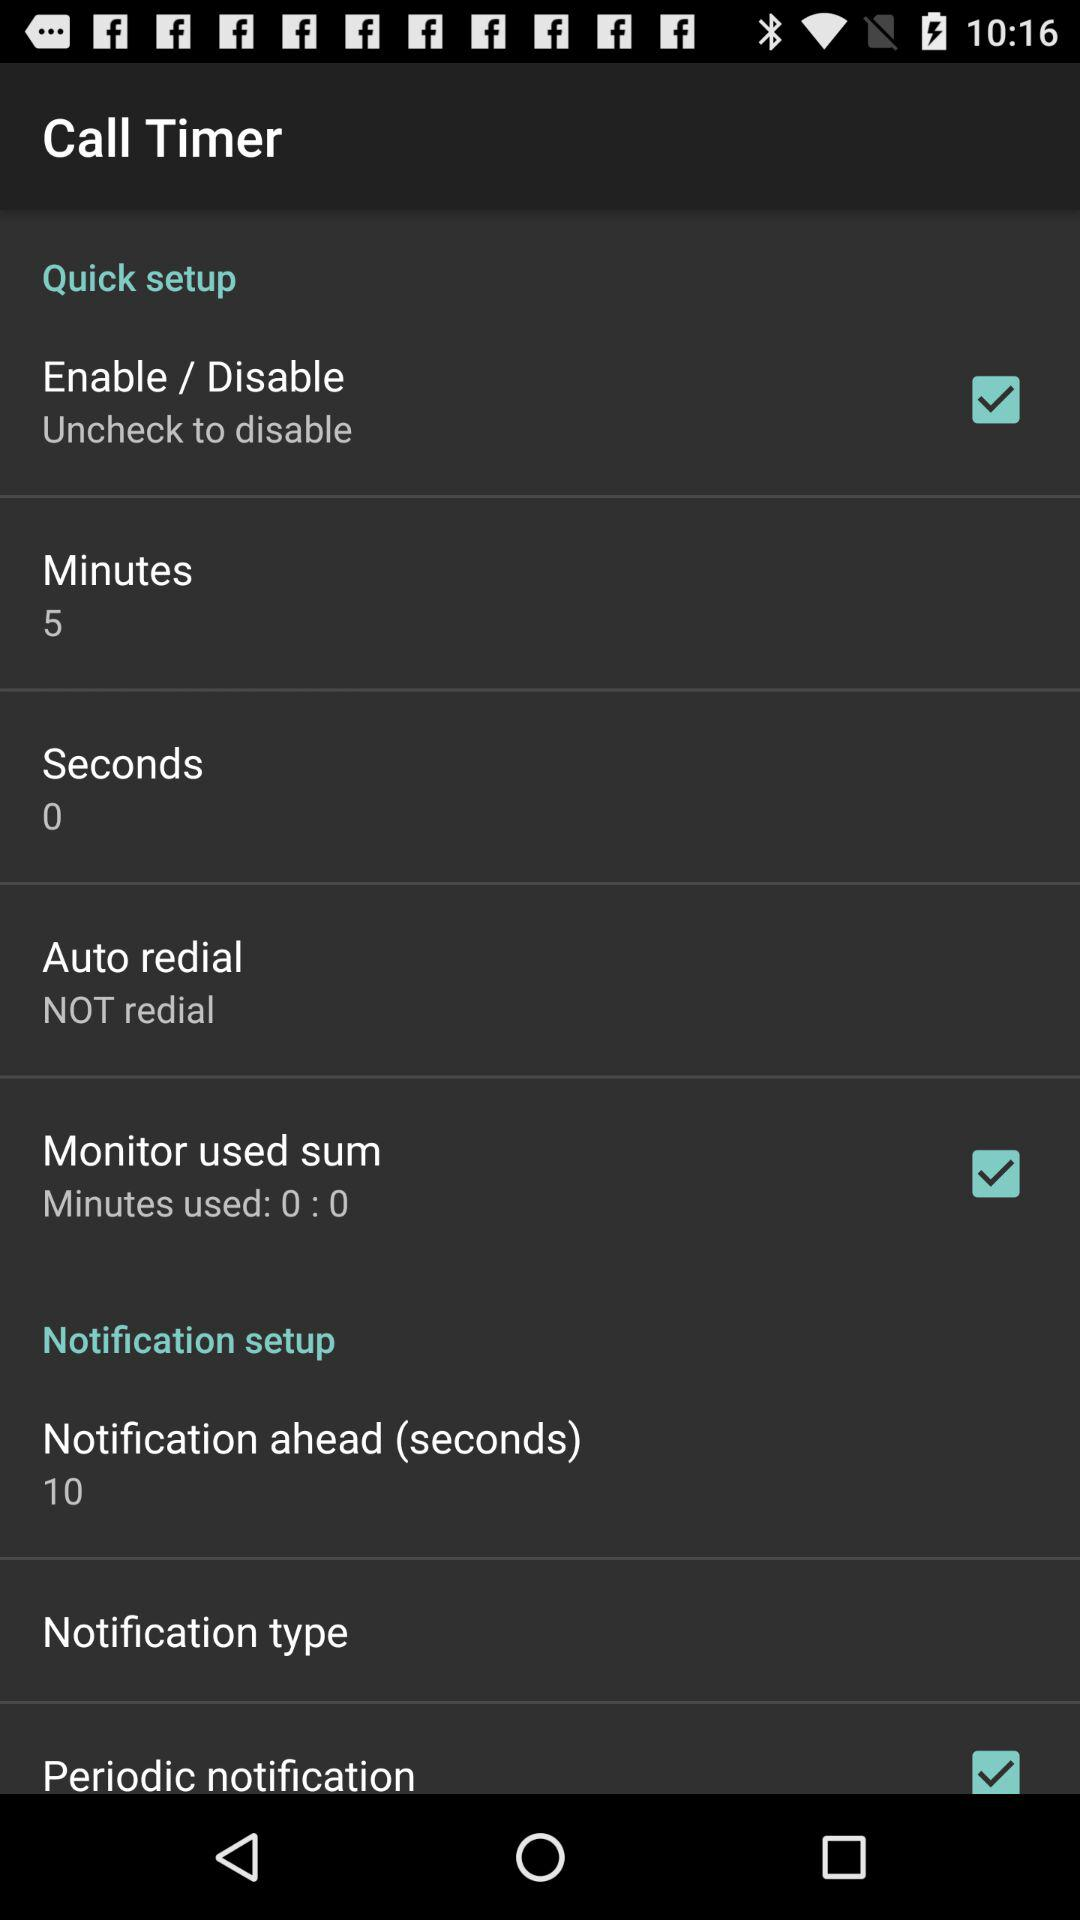What minutes of use are given in the " Monitor used sum setting"? The minutes are 0:0. 